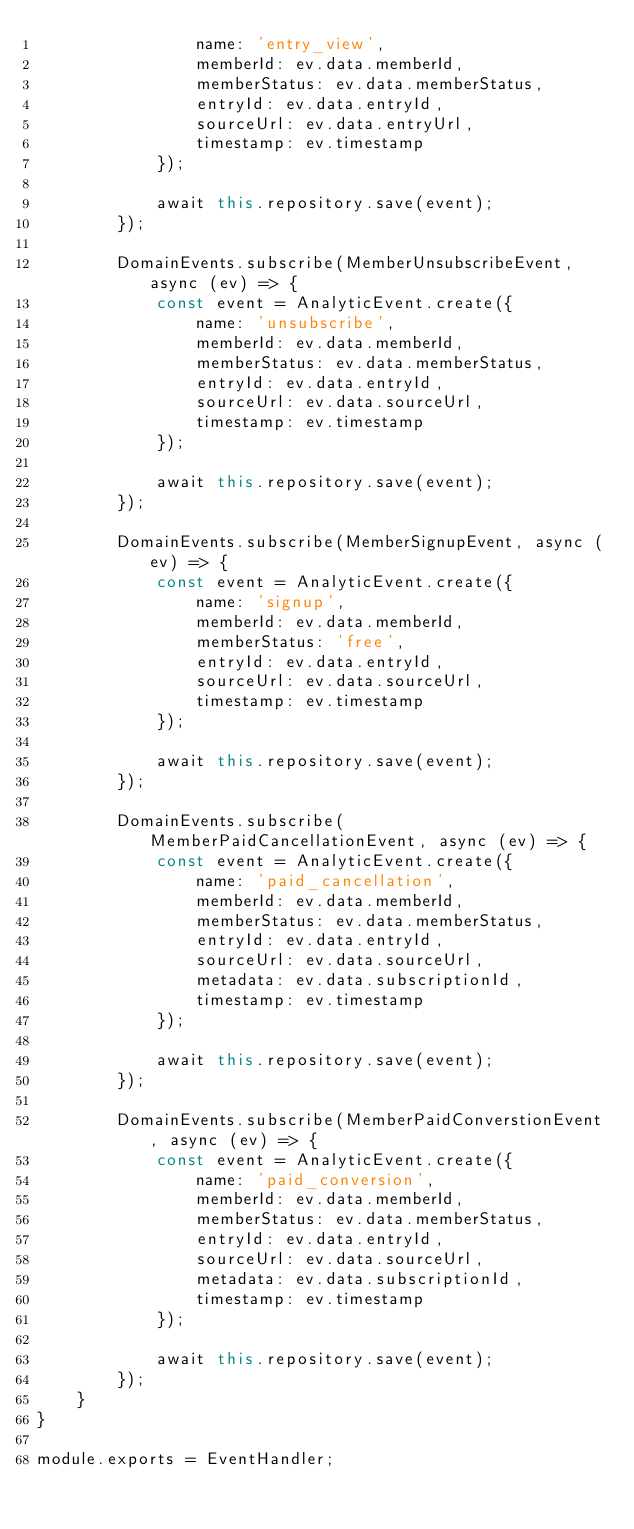<code> <loc_0><loc_0><loc_500><loc_500><_JavaScript_>                name: 'entry_view',
                memberId: ev.data.memberId,
                memberStatus: ev.data.memberStatus,
                entryId: ev.data.entryId,
                sourceUrl: ev.data.entryUrl,
                timestamp: ev.timestamp
            });

            await this.repository.save(event);
        });

        DomainEvents.subscribe(MemberUnsubscribeEvent, async (ev) => {
            const event = AnalyticEvent.create({
                name: 'unsubscribe',
                memberId: ev.data.memberId,
                memberStatus: ev.data.memberStatus,
                entryId: ev.data.entryId,
                sourceUrl: ev.data.sourceUrl,
                timestamp: ev.timestamp
            });

            await this.repository.save(event);
        });

        DomainEvents.subscribe(MemberSignupEvent, async (ev) => {
            const event = AnalyticEvent.create({
                name: 'signup',
                memberId: ev.data.memberId,
                memberStatus: 'free',
                entryId: ev.data.entryId,
                sourceUrl: ev.data.sourceUrl,
                timestamp: ev.timestamp
            });

            await this.repository.save(event);
        });

        DomainEvents.subscribe(MemberPaidCancellationEvent, async (ev) => {
            const event = AnalyticEvent.create({
                name: 'paid_cancellation',
                memberId: ev.data.memberId,
                memberStatus: ev.data.memberStatus,
                entryId: ev.data.entryId,
                sourceUrl: ev.data.sourceUrl,
                metadata: ev.data.subscriptionId,
                timestamp: ev.timestamp
            });

            await this.repository.save(event);
        });

        DomainEvents.subscribe(MemberPaidConverstionEvent, async (ev) => {
            const event = AnalyticEvent.create({
                name: 'paid_conversion',
                memberId: ev.data.memberId,
                memberStatus: ev.data.memberStatus,
                entryId: ev.data.entryId,
                sourceUrl: ev.data.sourceUrl,
                metadata: ev.data.subscriptionId,
                timestamp: ev.timestamp
            });

            await this.repository.save(event);
        });
    }
}

module.exports = EventHandler;
</code> 